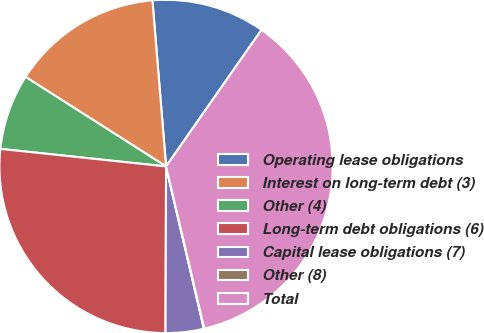Convert chart. <chart><loc_0><loc_0><loc_500><loc_500><pie_chart><fcel>Operating lease obligations<fcel>Interest on long-term debt (3)<fcel>Other (4)<fcel>Long-term debt obligations (6)<fcel>Capital lease obligations (7)<fcel>Other (8)<fcel>Total<nl><fcel>11.01%<fcel>14.67%<fcel>7.35%<fcel>26.63%<fcel>3.7%<fcel>0.04%<fcel>36.61%<nl></chart> 